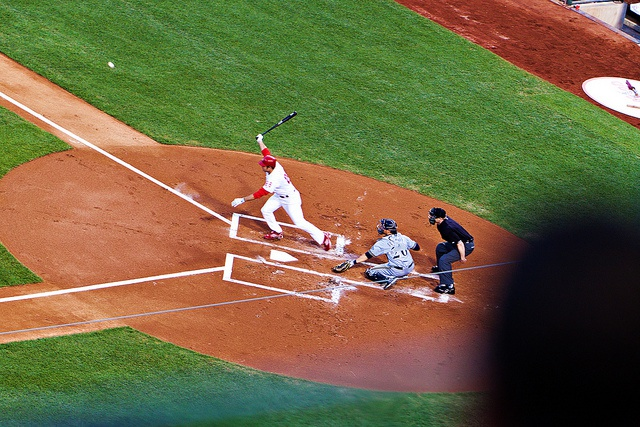Describe the objects in this image and their specific colors. I can see people in green, white, brown, red, and maroon tones, people in green, black, navy, lightpink, and lightgray tones, people in green, lavender, darkgray, and black tones, baseball glove in green, black, darkgray, gray, and lightgray tones, and baseball bat in green, black, navy, and olive tones in this image. 